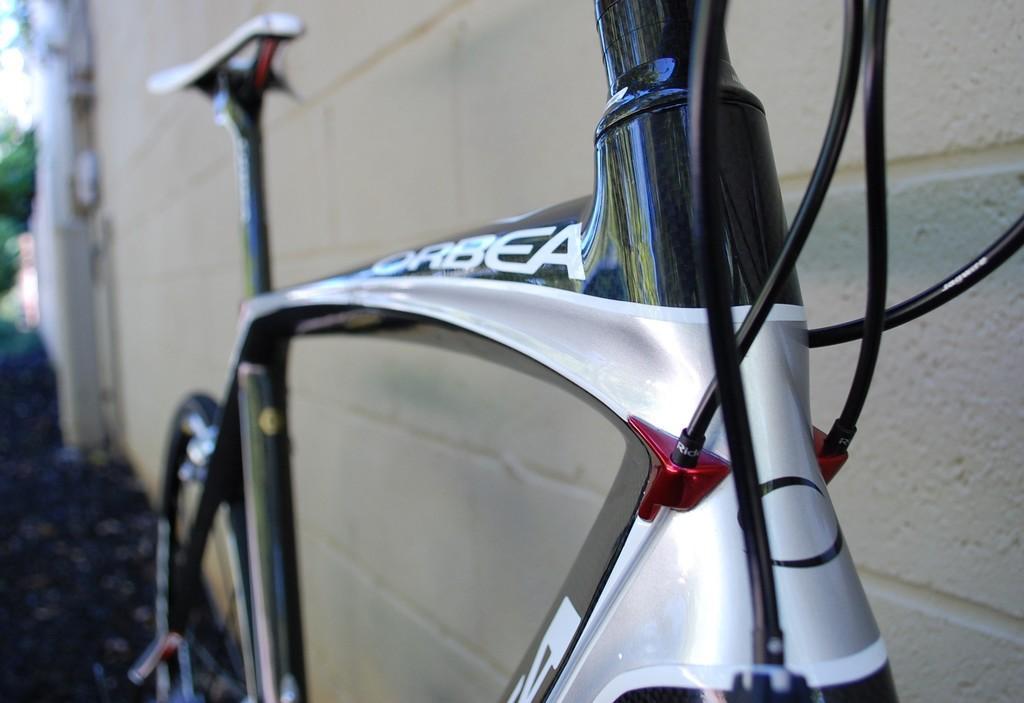Please provide a concise description of this image. In this image we can see a bicycle with cables placed on the ground. In the background, we can see building, tree and the sky. 